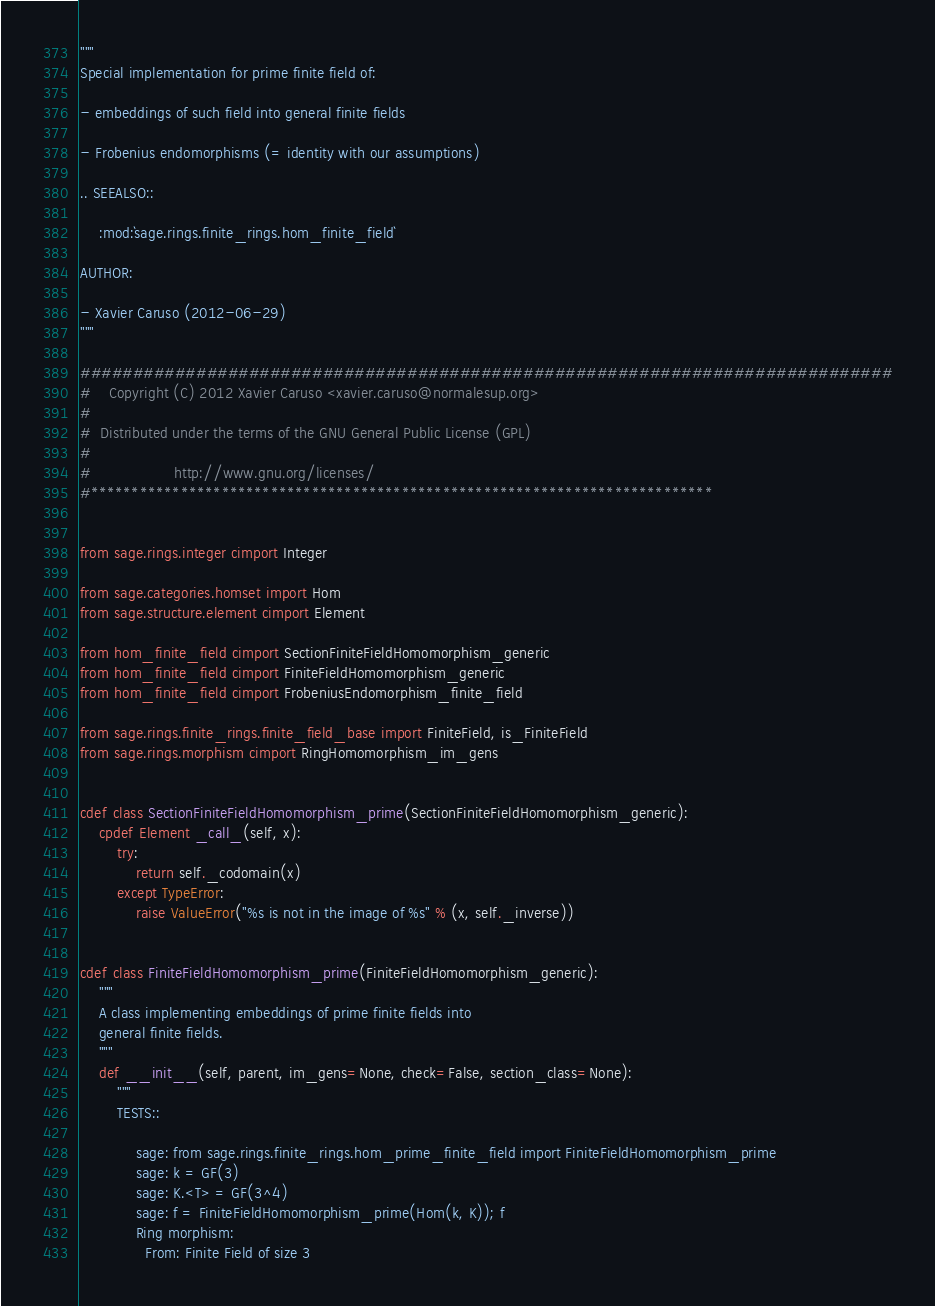<code> <loc_0><loc_0><loc_500><loc_500><_Cython_>"""
Special implementation for prime finite field of:

- embeddings of such field into general finite fields

- Frobenius endomorphisms (= identity with our assumptions)

.. SEEALSO::

    :mod:`sage.rings.finite_rings.hom_finite_field`

AUTHOR:

- Xavier Caruso (2012-06-29)
"""

#############################################################################
#    Copyright (C) 2012 Xavier Caruso <xavier.caruso@normalesup.org>
#
#  Distributed under the terms of the GNU General Public License (GPL)
#
#                  http://www.gnu.org/licenses/
#****************************************************************************


from sage.rings.integer cimport Integer

from sage.categories.homset import Hom
from sage.structure.element cimport Element

from hom_finite_field cimport SectionFiniteFieldHomomorphism_generic
from hom_finite_field cimport FiniteFieldHomomorphism_generic
from hom_finite_field cimport FrobeniusEndomorphism_finite_field

from sage.rings.finite_rings.finite_field_base import FiniteField, is_FiniteField
from sage.rings.morphism cimport RingHomomorphism_im_gens


cdef class SectionFiniteFieldHomomorphism_prime(SectionFiniteFieldHomomorphism_generic):
    cpdef Element _call_(self, x):
        try:
            return self._codomain(x)
        except TypeError:
            raise ValueError("%s is not in the image of %s" % (x, self._inverse))


cdef class FiniteFieldHomomorphism_prime(FiniteFieldHomomorphism_generic):
    """
    A class implementing embeddings of prime finite fields into
    general finite fields.
    """
    def __init__(self, parent, im_gens=None, check=False, section_class=None):
        """
        TESTS::

            sage: from sage.rings.finite_rings.hom_prime_finite_field import FiniteFieldHomomorphism_prime
            sage: k = GF(3)
            sage: K.<T> = GF(3^4)
            sage: f = FiniteFieldHomomorphism_prime(Hom(k, K)); f
            Ring morphism:
              From: Finite Field of size 3</code> 